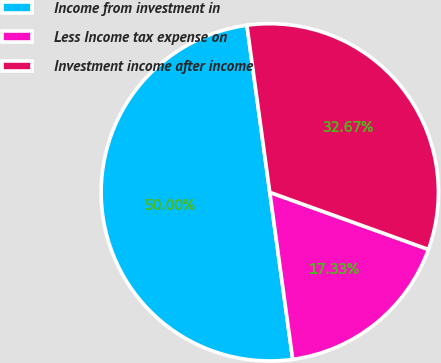<chart> <loc_0><loc_0><loc_500><loc_500><pie_chart><fcel>Income from investment in<fcel>Less Income tax expense on<fcel>Investment income after income<nl><fcel>50.0%<fcel>17.33%<fcel>32.67%<nl></chart> 